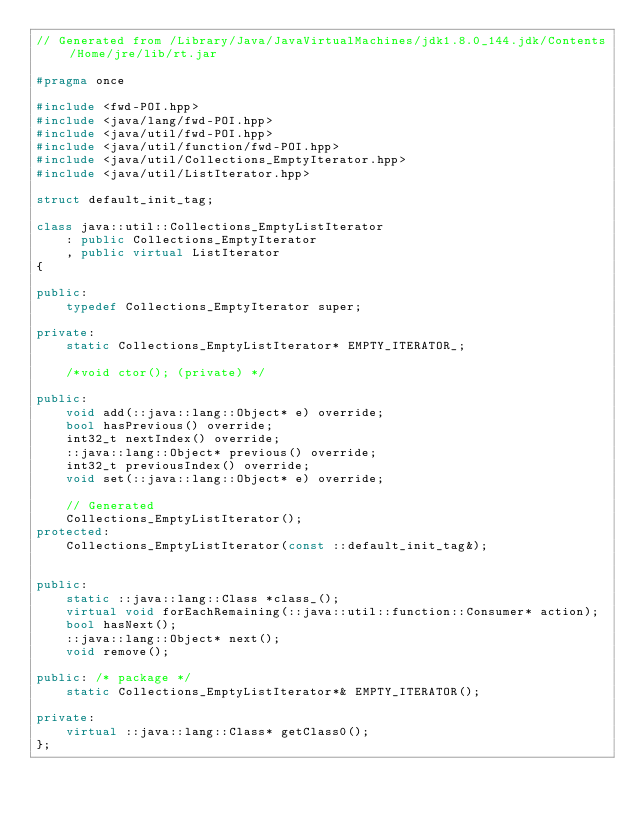<code> <loc_0><loc_0><loc_500><loc_500><_C++_>// Generated from /Library/Java/JavaVirtualMachines/jdk1.8.0_144.jdk/Contents/Home/jre/lib/rt.jar

#pragma once

#include <fwd-POI.hpp>
#include <java/lang/fwd-POI.hpp>
#include <java/util/fwd-POI.hpp>
#include <java/util/function/fwd-POI.hpp>
#include <java/util/Collections_EmptyIterator.hpp>
#include <java/util/ListIterator.hpp>

struct default_init_tag;

class java::util::Collections_EmptyListIterator
    : public Collections_EmptyIterator
    , public virtual ListIterator
{

public:
    typedef Collections_EmptyIterator super;

private:
    static Collections_EmptyListIterator* EMPTY_ITERATOR_;

    /*void ctor(); (private) */

public:
    void add(::java::lang::Object* e) override;
    bool hasPrevious() override;
    int32_t nextIndex() override;
    ::java::lang::Object* previous() override;
    int32_t previousIndex() override;
    void set(::java::lang::Object* e) override;

    // Generated
    Collections_EmptyListIterator();
protected:
    Collections_EmptyListIterator(const ::default_init_tag&);


public:
    static ::java::lang::Class *class_();
    virtual void forEachRemaining(::java::util::function::Consumer* action);
    bool hasNext();
    ::java::lang::Object* next();
    void remove();

public: /* package */
    static Collections_EmptyListIterator*& EMPTY_ITERATOR();

private:
    virtual ::java::lang::Class* getClass0();
};
</code> 